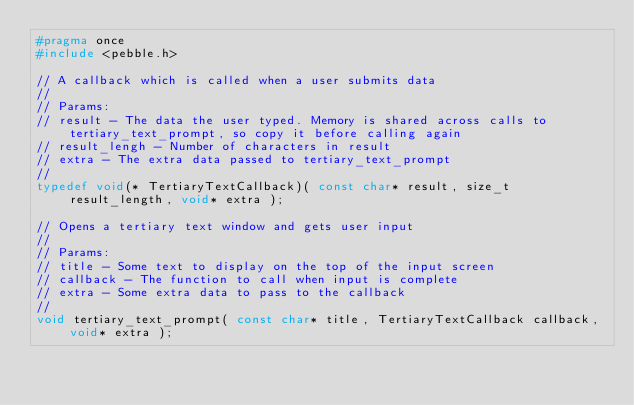<code> <loc_0><loc_0><loc_500><loc_500><_C_>#pragma once
#include <pebble.h>

// A callback which is called when a user submits data
//
// Params:
// result - The data the user typed. Memory is shared across calls to tertiary_text_prompt, so copy it before calling again
// result_lengh - Number of characters in result
// extra - The extra data passed to tertiary_text_prompt
//
typedef void(* TertiaryTextCallback)( const char* result, size_t result_length, void* extra );

// Opens a tertiary text window and gets user input
//
// Params:
// title - Some text to display on the top of the input screen
// callback - The function to call when input is complete
// extra - Some extra data to pass to the callback
//
void tertiary_text_prompt( const char* title, TertiaryTextCallback callback, void* extra );</code> 